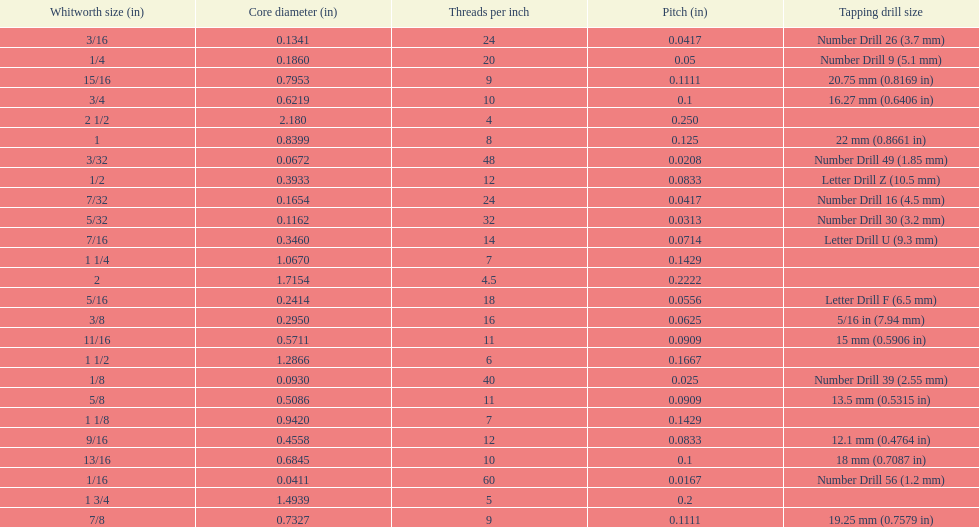What is the core diameter of the first 1/8 whitworth size (in)? 0.0930. 